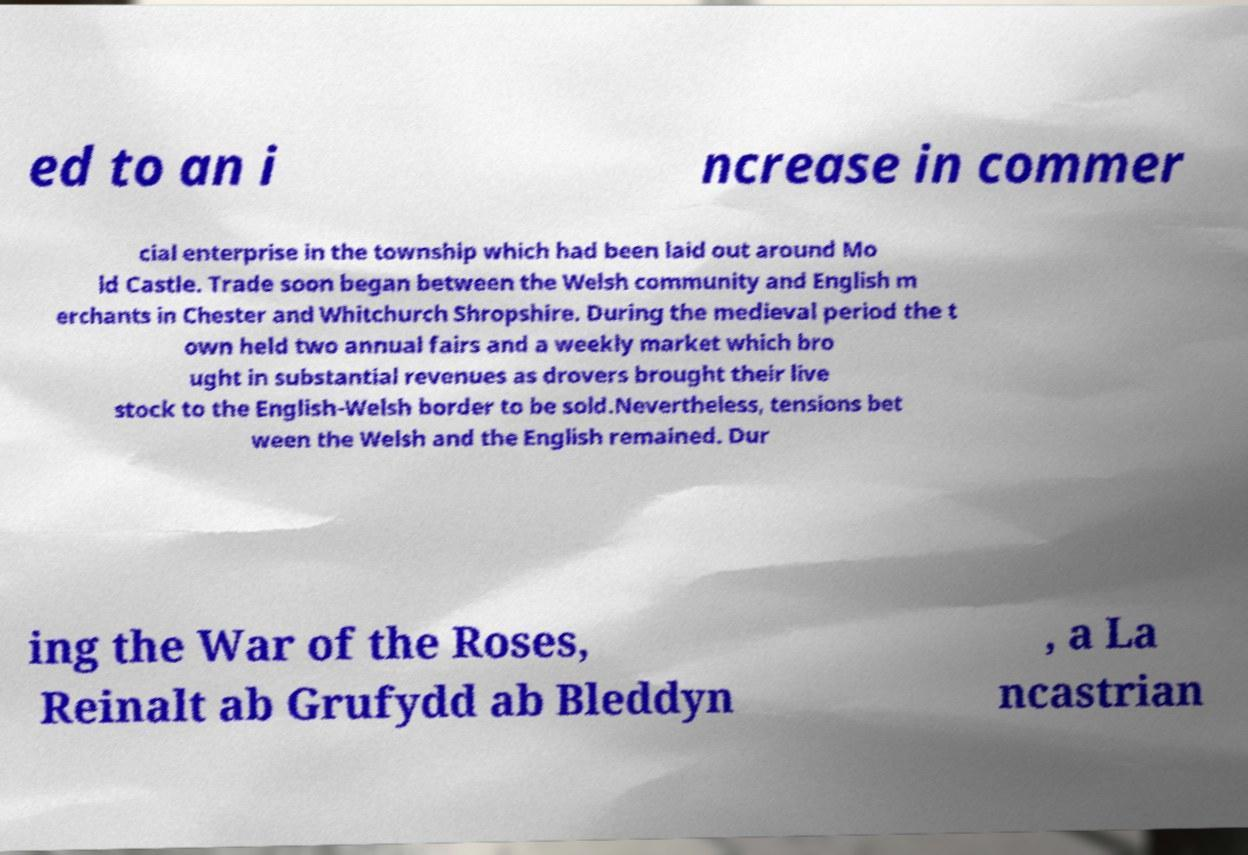What messages or text are displayed in this image? I need them in a readable, typed format. ed to an i ncrease in commer cial enterprise in the township which had been laid out around Mo ld Castle. Trade soon began between the Welsh community and English m erchants in Chester and Whitchurch Shropshire. During the medieval period the t own held two annual fairs and a weekly market which bro ught in substantial revenues as drovers brought their live stock to the English-Welsh border to be sold.Nevertheless, tensions bet ween the Welsh and the English remained. Dur ing the War of the Roses, Reinalt ab Grufydd ab Bleddyn , a La ncastrian 